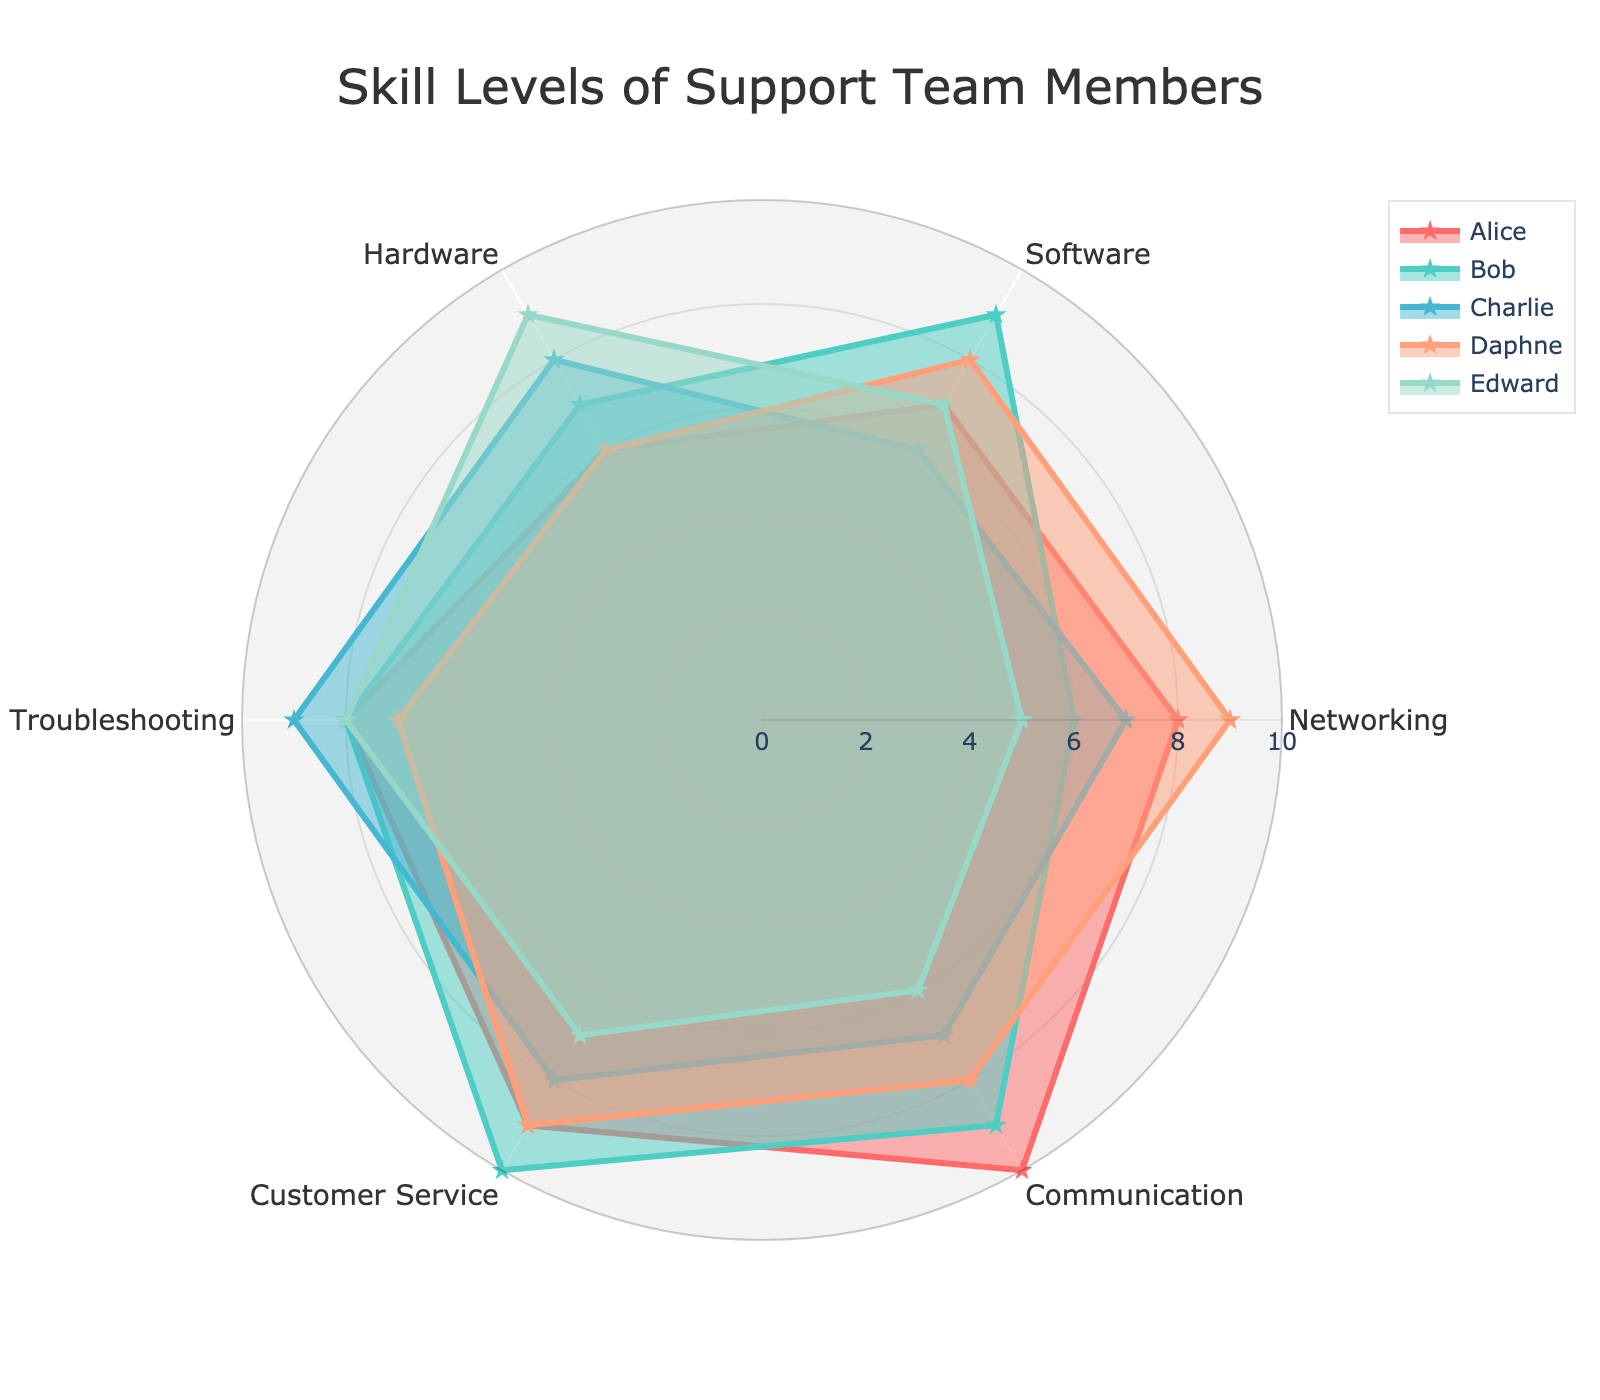what is the title of the chart? The title of the chart is prominently displayed at the top. It is centered and described in a larger font size.
Answer: Skill Levels of Support Team Members how many categories are shown in the radar chart? The chart has labeled axes radiating from the center, each representing a different technical area. Counting these labels gives the total.
Answer: 6 which team member has the highest skill level in communication? Identify the outermost point on the 'Communication' axis by tracking each data line and looking at the corresponding labels.
Answer: Alice what is Edward's skill level in hardware? Follow Edward's line (associated with his color) to the 'Hardware' axis and read the value where it intersects.
Answer: 9 What is the average skill level for Bob across all categories? Sum Bob's skill levels in all six categories and then divide by 6 to find the average.
Answer: (6+9+7+8+10+9)/6 = 8.167 Whose skill level in software is closest to the group's average skill level in that category? Compute the average by summing the software scores and dividing by 5. Then determine the minimal absolute difference between this average and each member’s score.
Answer: Average = (7+9+6+8+7)/5 = 7.4, Daphne's 8 is closest Which team member shows the most balanced skills across all categories? Look for the radar plot having the smallest variation; visually check if any shape is closest to a regular polygon without sharp peaks or dips.
Answer: Charlie Whose skills in networking and troubleshooting are both above 8? Track each member’s values for networking and troubleshooting. Identify those exceeding 8 in both categories.
Answer: Alice and Daphne compare the skill levels of Alice and Bob in customer service. Who scores higher? Trace Alice’s and Bob’s lines to the 'Customer Service' axis. Compare these values.
Answer: Bob who has the lowest skill level in networking, and what’s the value? Identify the lowest value on the 'Networking' axis by examining where each team member's polygon intersects with this axis.
Answer: Edward, 5 